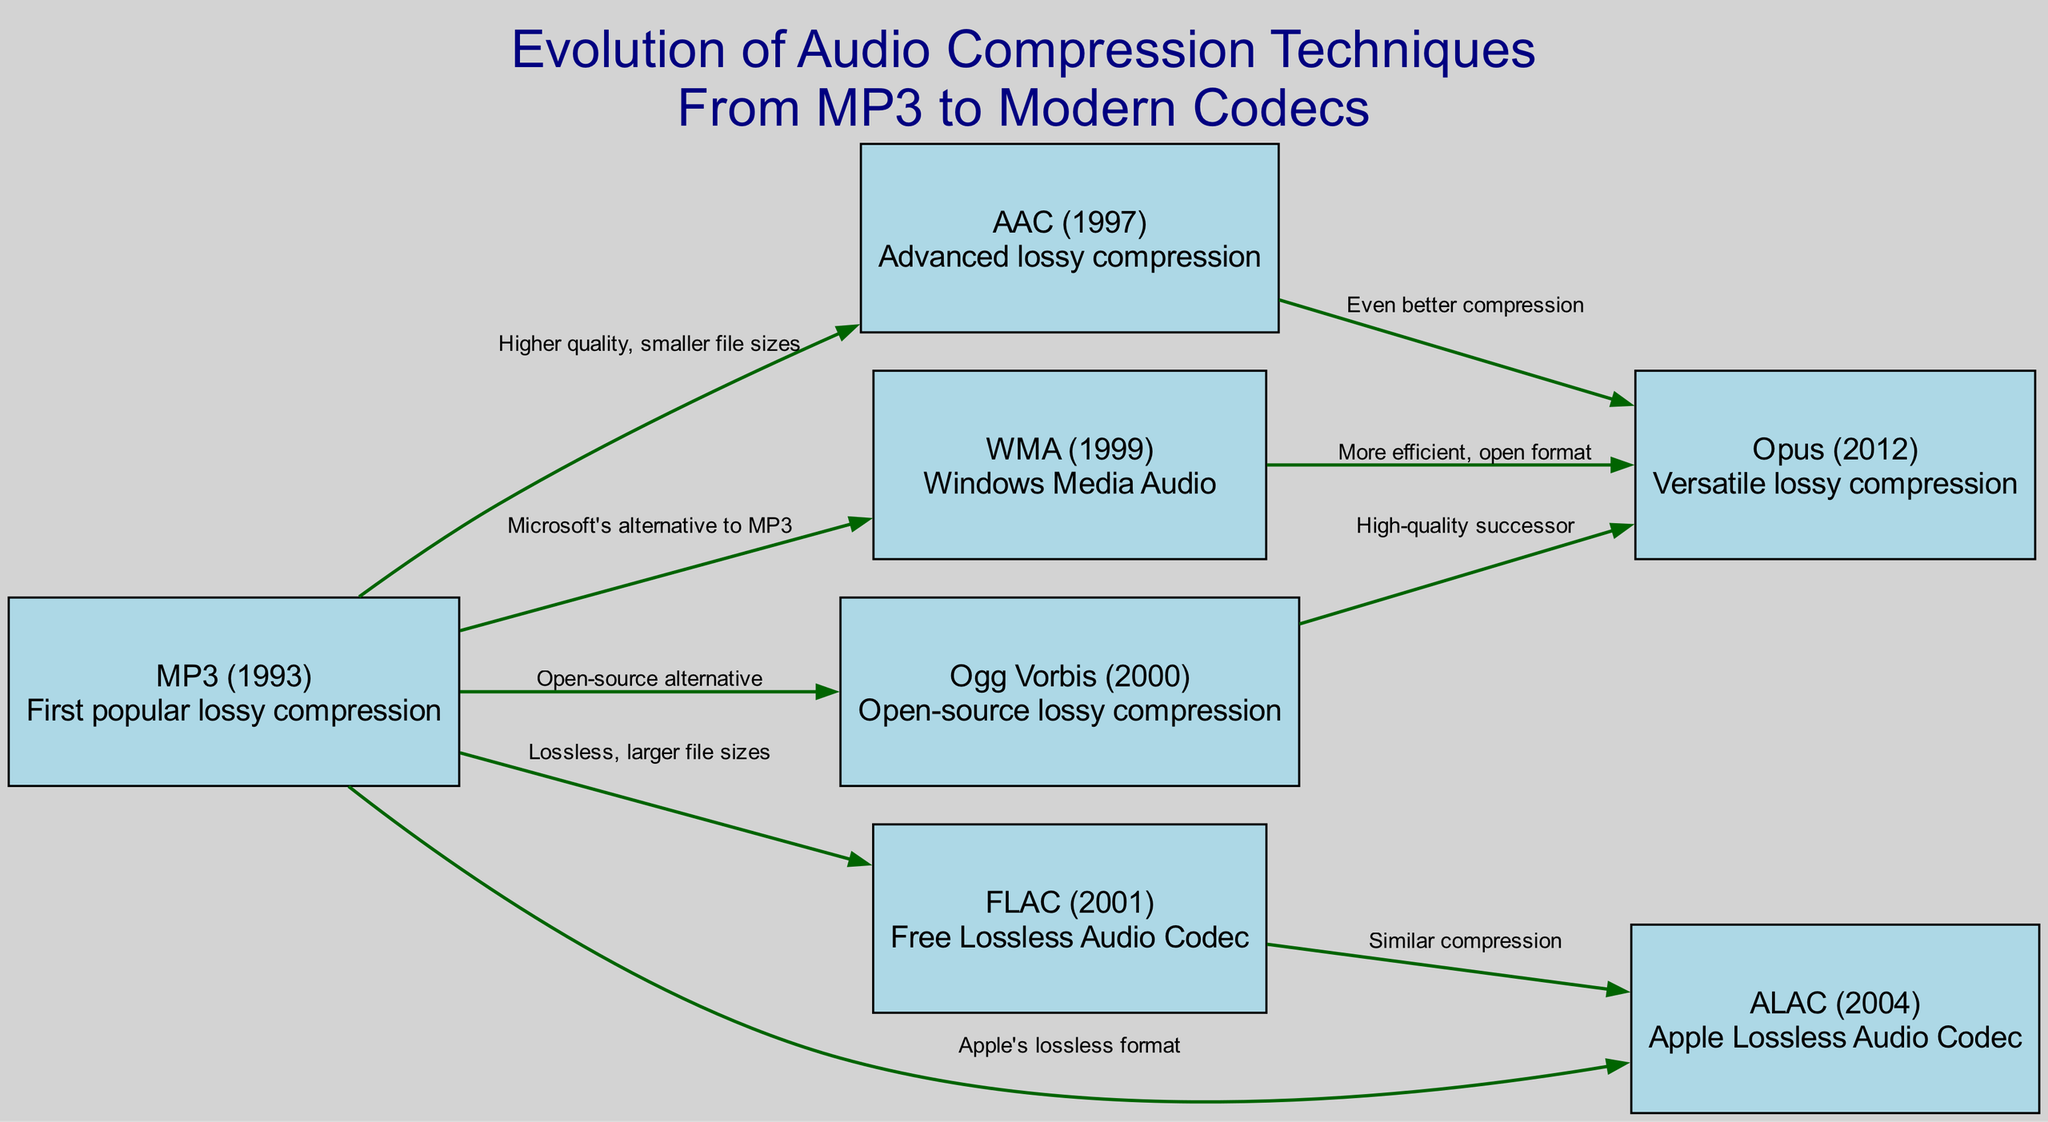What is the first popular lossy compression method? The diagram indicates that MP3, introduced in 1993, is the first popular lossy compression method.
Answer: MP3 Which codec was developed in 1997? According to the diagram, the codec developed in 1997 is AAC.
Answer: AAC How many edges are connected to the Ogg Vorbis node? By examining the diagram, Ogg Vorbis has three outgoing edges indicating its connections to Opus, MP3, and WMA.
Answer: 3 What is the relationship between AAC and Opus? The diagram shows that AAC leads to Opus, indicating that Opus offers even better compression than AAC.
Answer: Even better compression What type of codec is FLAC? The description for FLAC in the diagram states that it is a Free Lossless Audio Codec.
Answer: Lossless Which codec serves as Microsoft's alternative to MP3? The diagram specifically states that WMA is Microsoft's alternative to MP3.
Answer: WMA What two codecs have similar compression? The diagram connects FLAC to ALAC with a label indicating they have similar compression.
Answer: FLAC and ALAC How has the audio compression technology progressed since MP3? The diagram outlines a progression from MP3 to newer codecs like AAC and Opus, highlighting improvements in quality and compression efficiency.
Answer: Quality and compression efficiency Which codecs are considered high-quality successors to MP3? The diagram identifies Opus as a high-quality successor, notably reassessing the previous technologies.
Answer: Opus 